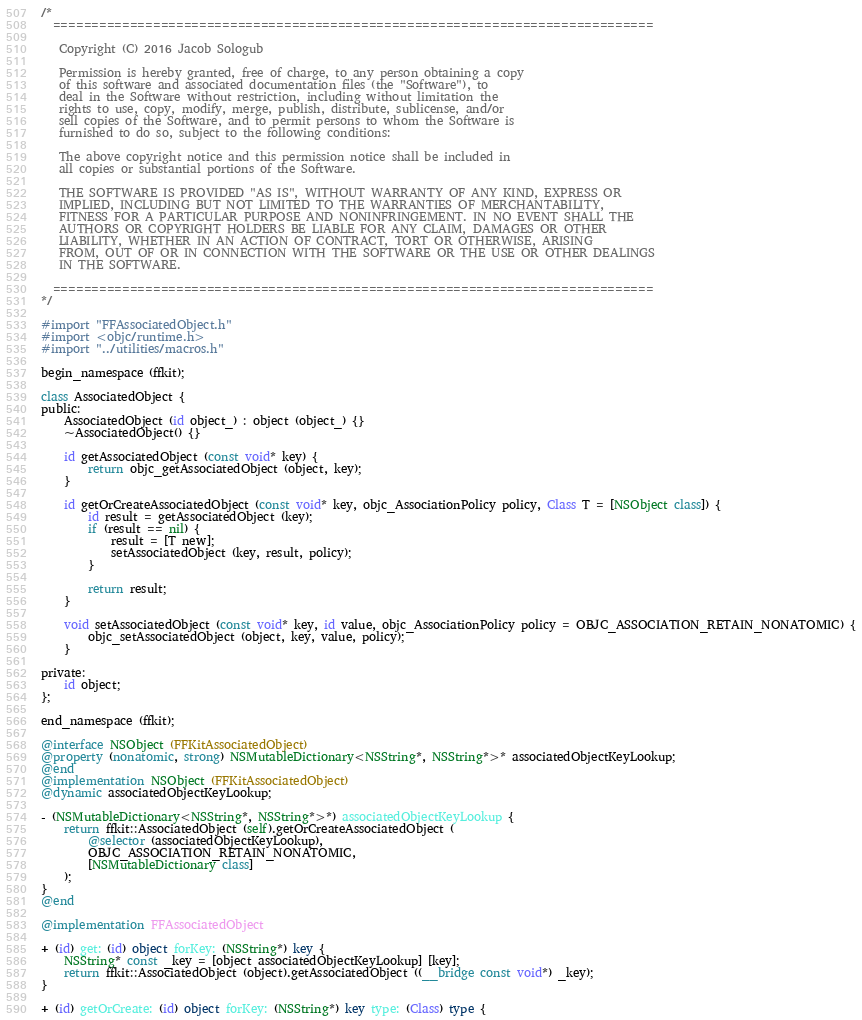<code> <loc_0><loc_0><loc_500><loc_500><_ObjectiveC_>/*
  ==============================================================================
 
   Copyright (C) 2016 Jacob Sologub

   Permission is hereby granted, free of charge, to any person obtaining a copy
   of this software and associated documentation files (the "Software"), to
   deal in the Software without restriction, including without limitation the
   rights to use, copy, modify, merge, publish, distribute, sublicense, and/or
   sell copies of the Software, and to permit persons to whom the Software is
   furnished to do so, subject to the following conditions:

   The above copyright notice and this permission notice shall be included in
   all copies or substantial portions of the Software.

   THE SOFTWARE IS PROVIDED "AS IS", WITHOUT WARRANTY OF ANY KIND, EXPRESS OR
   IMPLIED, INCLUDING BUT NOT LIMITED TO THE WARRANTIES OF MERCHANTABILITY,
   FITNESS FOR A PARTICULAR PURPOSE AND NONINFRINGEMENT. IN NO EVENT SHALL THE
   AUTHORS OR COPYRIGHT HOLDERS BE LIABLE FOR ANY CLAIM, DAMAGES OR OTHER
   LIABILITY, WHETHER IN AN ACTION OF CONTRACT, TORT OR OTHERWISE, ARISING
   FROM, OUT OF OR IN CONNECTION WITH THE SOFTWARE OR THE USE OR OTHER DEALINGS
   IN THE SOFTWARE.
 
  ==============================================================================
*/

#import "FFAssociatedObject.h"
#import <objc/runtime.h>
#import "../utilities/macros.h"

begin_namespace (ffkit);

class AssociatedObject {
public:
    AssociatedObject (id object_) : object (object_) {}
    ~AssociatedObject() {}
    
    id getAssociatedObject (const void* key) {
        return objc_getAssociatedObject (object, key);
    }
    
    id getOrCreateAssociatedObject (const void* key, objc_AssociationPolicy policy, Class T = [NSObject class]) {
        id result = getAssociatedObject (key);
        if (result == nil) {
            result = [T new];
            setAssociatedObject (key, result, policy);
        }
        
        return result;
    }
    
    void setAssociatedObject (const void* key, id value, objc_AssociationPolicy policy = OBJC_ASSOCIATION_RETAIN_NONATOMIC) {
        objc_setAssociatedObject (object, key, value, policy);
    }
    
private:
    id object;
};

end_namespace (ffkit);

@interface NSObject (FFKitAssociatedObject)
@property (nonatomic, strong) NSMutableDictionary<NSString*, NSString*>* associatedObjectKeyLookup;
@end
@implementation NSObject (FFKitAssociatedObject)
@dynamic associatedObjectKeyLookup;

- (NSMutableDictionary<NSString*, NSString*>*) associatedObjectKeyLookup {
    return ffkit::AssociatedObject (self).getOrCreateAssociatedObject (
        @selector (associatedObjectKeyLookup),
        OBJC_ASSOCIATION_RETAIN_NONATOMIC,
        [NSMutableDictionary class]
    );
}
@end

@implementation FFAssociatedObject

+ (id) get: (id) object forKey: (NSString*) key {
    NSString* const _key = [object associatedObjectKeyLookup] [key];
    return ffkit::AssociatedObject (object).getAssociatedObject ((__bridge const void*) _key);
}

+ (id) getOrCreate: (id) object forKey: (NSString*) key type: (Class) type {</code> 